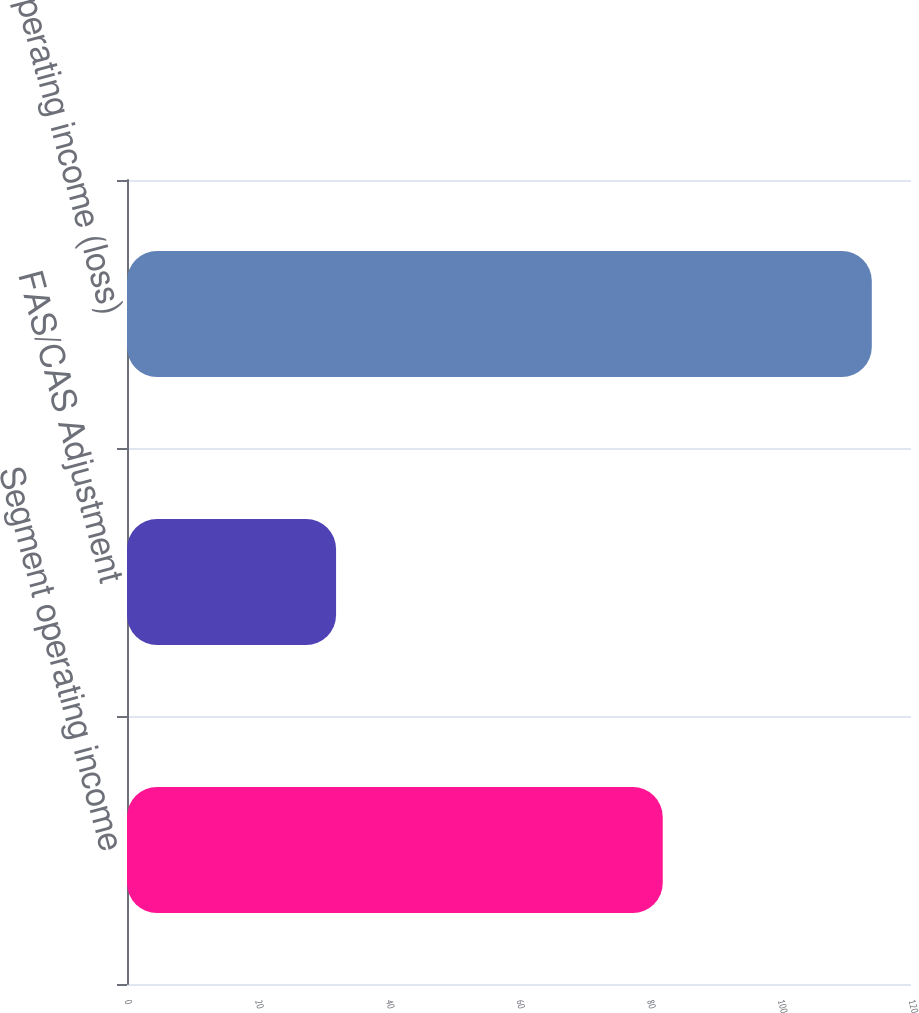<chart> <loc_0><loc_0><loc_500><loc_500><bar_chart><fcel>Segment operating income<fcel>FAS/CAS Adjustment<fcel>Total operating income (loss)<nl><fcel>82<fcel>32<fcel>114<nl></chart> 